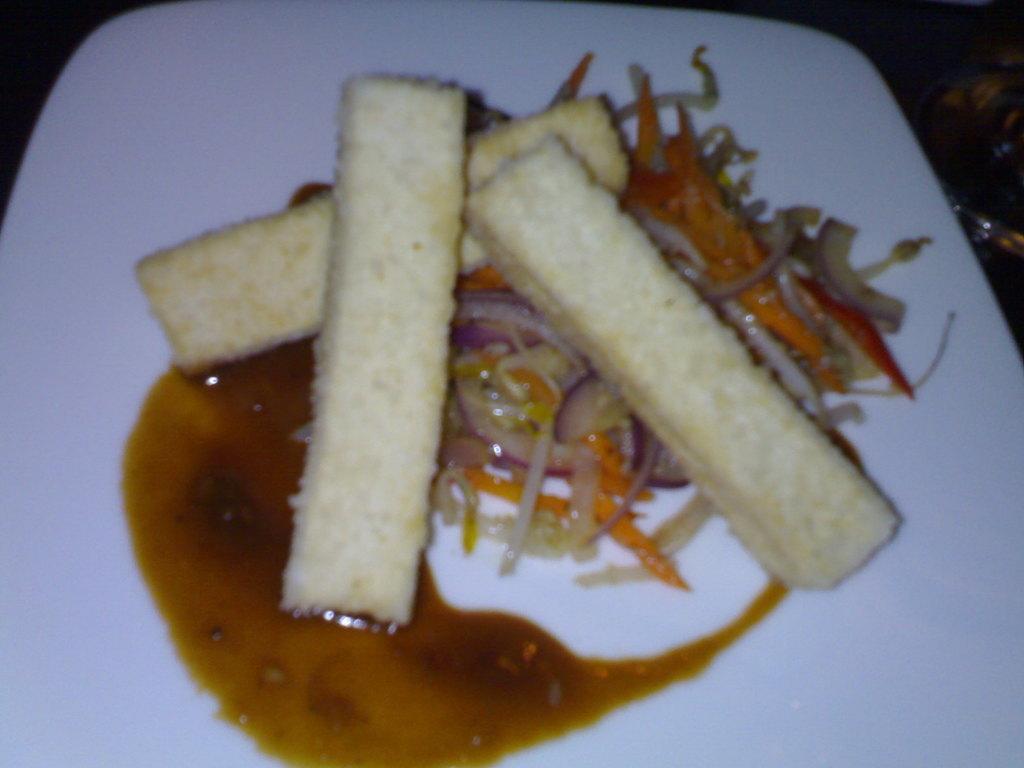In one or two sentences, can you explain what this image depicts? There is a white plate. On that there is a food item with onion pieces and some other things. 